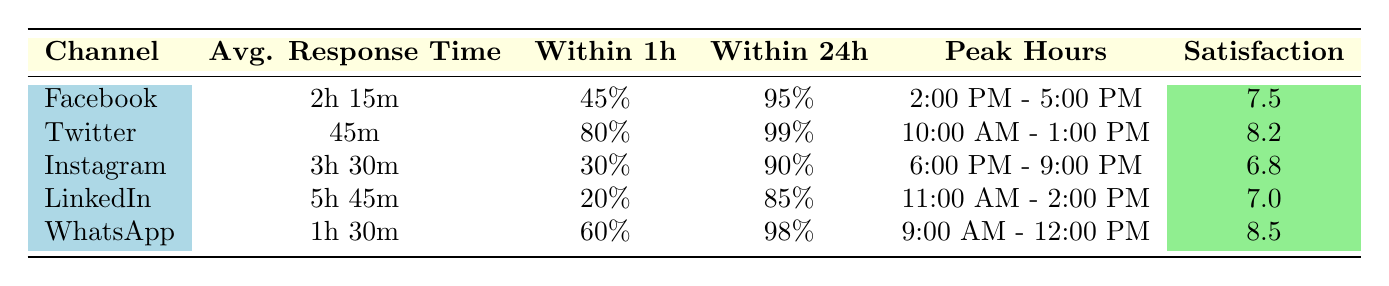What is the average response time for Twitter? The table indicates that the average response time for Twitter is listed as 45 minutes. This information can be directly retrieved from the "Avg. Response Time" column corresponding to the Twitter row.
Answer: 45 minutes Which channel has the highest percentage of inquiries resolved within one hour? By looking at the "Within 1h" column, Twitter has the highest percentage at 80%. This is the largest value in that column after checking all channels.
Answer: Twitter What is the average customer satisfaction score for WhatsApp and Twitter combined? The satisfaction scores for WhatsApp and Twitter are 8.5 and 8.2 respectively. To find the average, we add these two scores (8.5 + 8.2 = 16.7) and then divide by 2, resulting in an average score of 8.35.
Answer: 8.35 Does Instagram have a higher response time than LinkedIn? According to the table, Instagram has a response time of 3 hours 30 minutes, while LinkedIn has a response time of 5 hours 45 minutes. Since 3 hours and 30 minutes is less than 5 hours and 45 minutes, the statement is false.
Answer: No Which social media channel has the highest satisfaction score and what is it? The satisfaction score for WhatsApp is 8.5, which is the highest in the "Satisfaction" column compared to all other channels. It can be confirmed by comparing the scores listed for each channel.
Answer: WhatsApp, 8.5 How many channels have a response time of more than 2 hours? From the table, Facebook, Instagram, and LinkedIn fall into the category of having response times greater than 2 hours, specifically with times of 2 hours 15 minutes, 3 hours 30 minutes, and 5 hours 45 minutes. Thus, there are three channels in total.
Answer: 3 What percentage of responses on Facebook are resolved within 24 hours? The table specifically indicates that for Facebook, 95% of inquiries are resolved within 24 hours. This is a direct retrieval from the corresponding row for Facebook in the "Within 24h" column.
Answer: 95% Which social media channel experiences peak inquiries between 11:00 AM and 2:00 PM? The table shows that LinkedIn has peak inquiry hours from 11:00 AM - 2:00 PM. This can be confirmed by looking at the "Peak Hours" column for each channel.
Answer: LinkedIn What is the difference in average response times between Twitter and WhatsApp? The average response time for Twitter is 45 minutes and for WhatsApp is 1 hour 30 minutes, which is equivalent to 90 minutes. To find the difference, we convert both times to minutes (45 and 90), and subtract: 90 - 45 = 45 minutes.
Answer: 45 minutes 